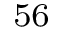<formula> <loc_0><loc_0><loc_500><loc_500>^ { 5 6 }</formula> 